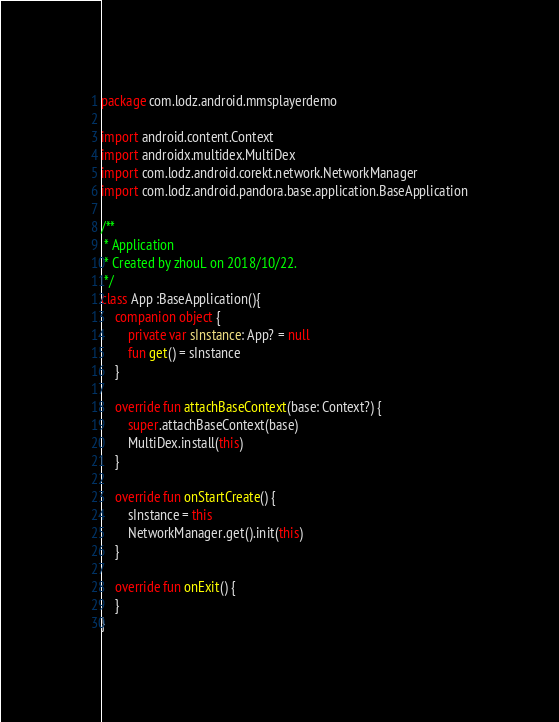Convert code to text. <code><loc_0><loc_0><loc_500><loc_500><_Kotlin_>package com.lodz.android.mmsplayerdemo

import android.content.Context
import androidx.multidex.MultiDex
import com.lodz.android.corekt.network.NetworkManager
import com.lodz.android.pandora.base.application.BaseApplication

/**
 * Application
 * Created by zhouL on 2018/10/22.
 */
class App :BaseApplication(){
    companion object {
        private var sInstance: App? = null
        fun get() = sInstance
    }

    override fun attachBaseContext(base: Context?) {
        super.attachBaseContext(base)
        MultiDex.install(this)
    }

    override fun onStartCreate() {
        sInstance = this
        NetworkManager.get().init(this)
    }

    override fun onExit() {
    }
}</code> 